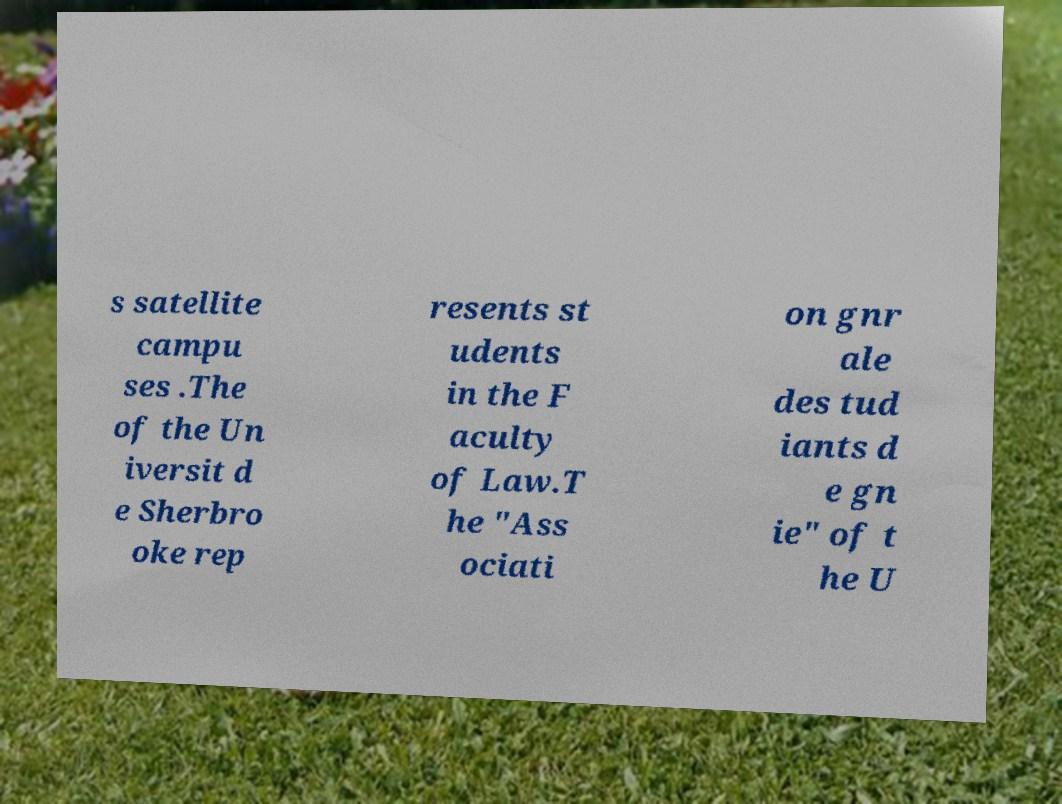Could you extract and type out the text from this image? s satellite campu ses .The of the Un iversit d e Sherbro oke rep resents st udents in the F aculty of Law.T he "Ass ociati on gnr ale des tud iants d e gn ie" of t he U 